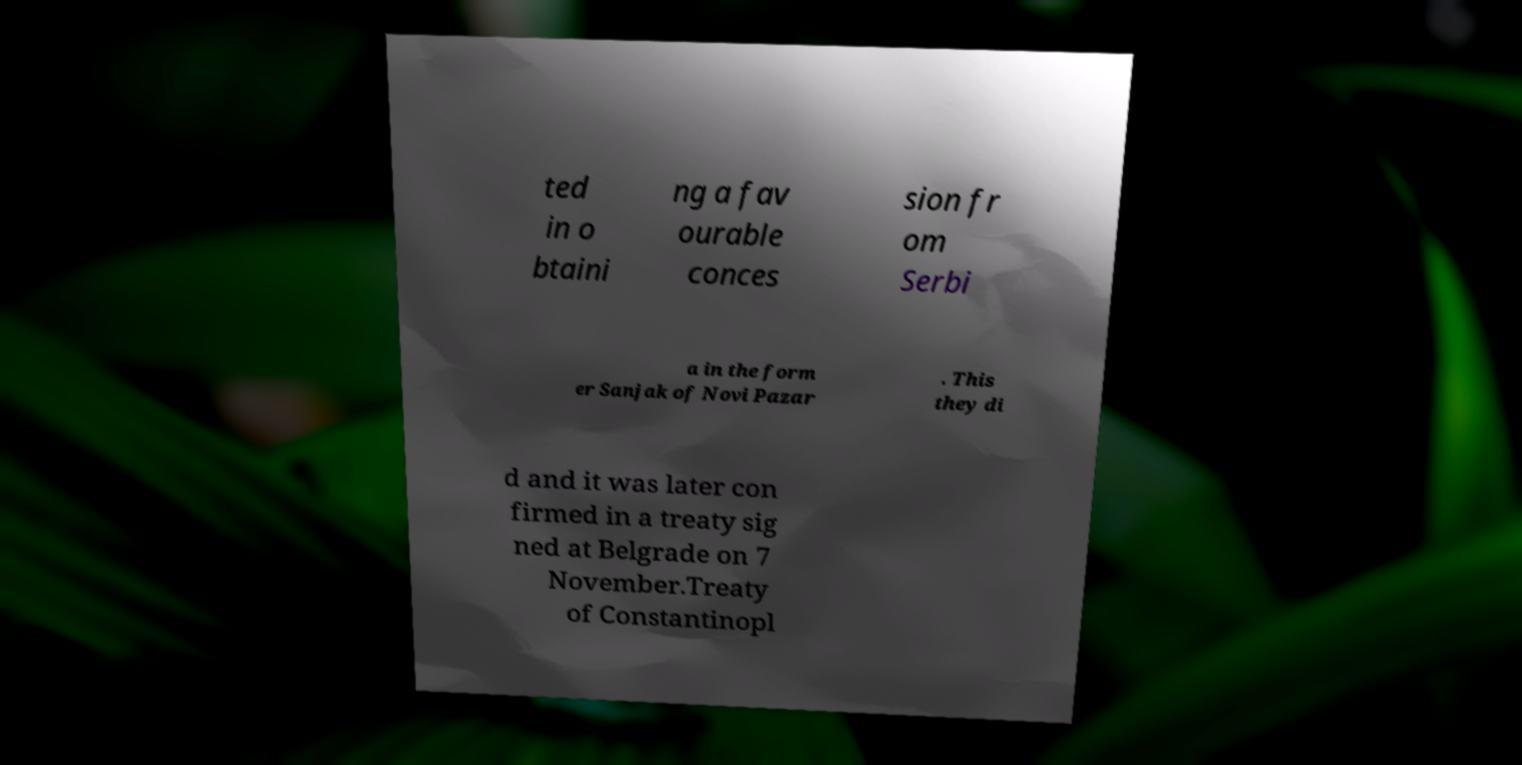There's text embedded in this image that I need extracted. Can you transcribe it verbatim? ted in o btaini ng a fav ourable conces sion fr om Serbi a in the form er Sanjak of Novi Pazar . This they di d and it was later con firmed in a treaty sig ned at Belgrade on 7 November.Treaty of Constantinopl 